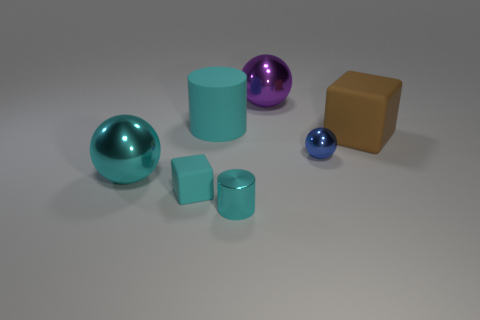Subtract all tiny metallic spheres. How many spheres are left? 2 Subtract all cyan spheres. How many spheres are left? 2 Subtract 2 cylinders. How many cylinders are left? 0 Subtract all balls. How many objects are left? 4 Add 1 blue metallic cylinders. How many objects exist? 8 Add 7 big purple spheres. How many big purple spheres exist? 8 Subtract 0 purple blocks. How many objects are left? 7 Subtract all green cylinders. Subtract all cyan spheres. How many cylinders are left? 2 Subtract all red cubes. How many purple balls are left? 1 Subtract all tiny cylinders. Subtract all large metallic objects. How many objects are left? 4 